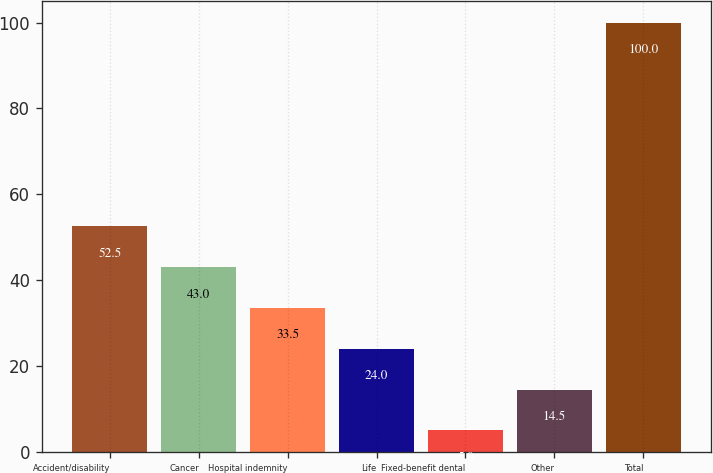<chart> <loc_0><loc_0><loc_500><loc_500><bar_chart><fcel>Accident/disability<fcel>Cancer<fcel>Hospital indemnity<fcel>Life<fcel>Fixed-benefit dental<fcel>Other<fcel>Total<nl><fcel>52.5<fcel>43<fcel>33.5<fcel>24<fcel>5<fcel>14.5<fcel>100<nl></chart> 